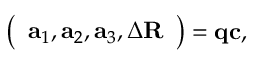<formula> <loc_0><loc_0><loc_500><loc_500>\left ( \begin{array} { l } { a _ { 1 } , a _ { 2 } , a _ { 3 } , \Delta R } \end{array} \right ) = q c ,</formula> 